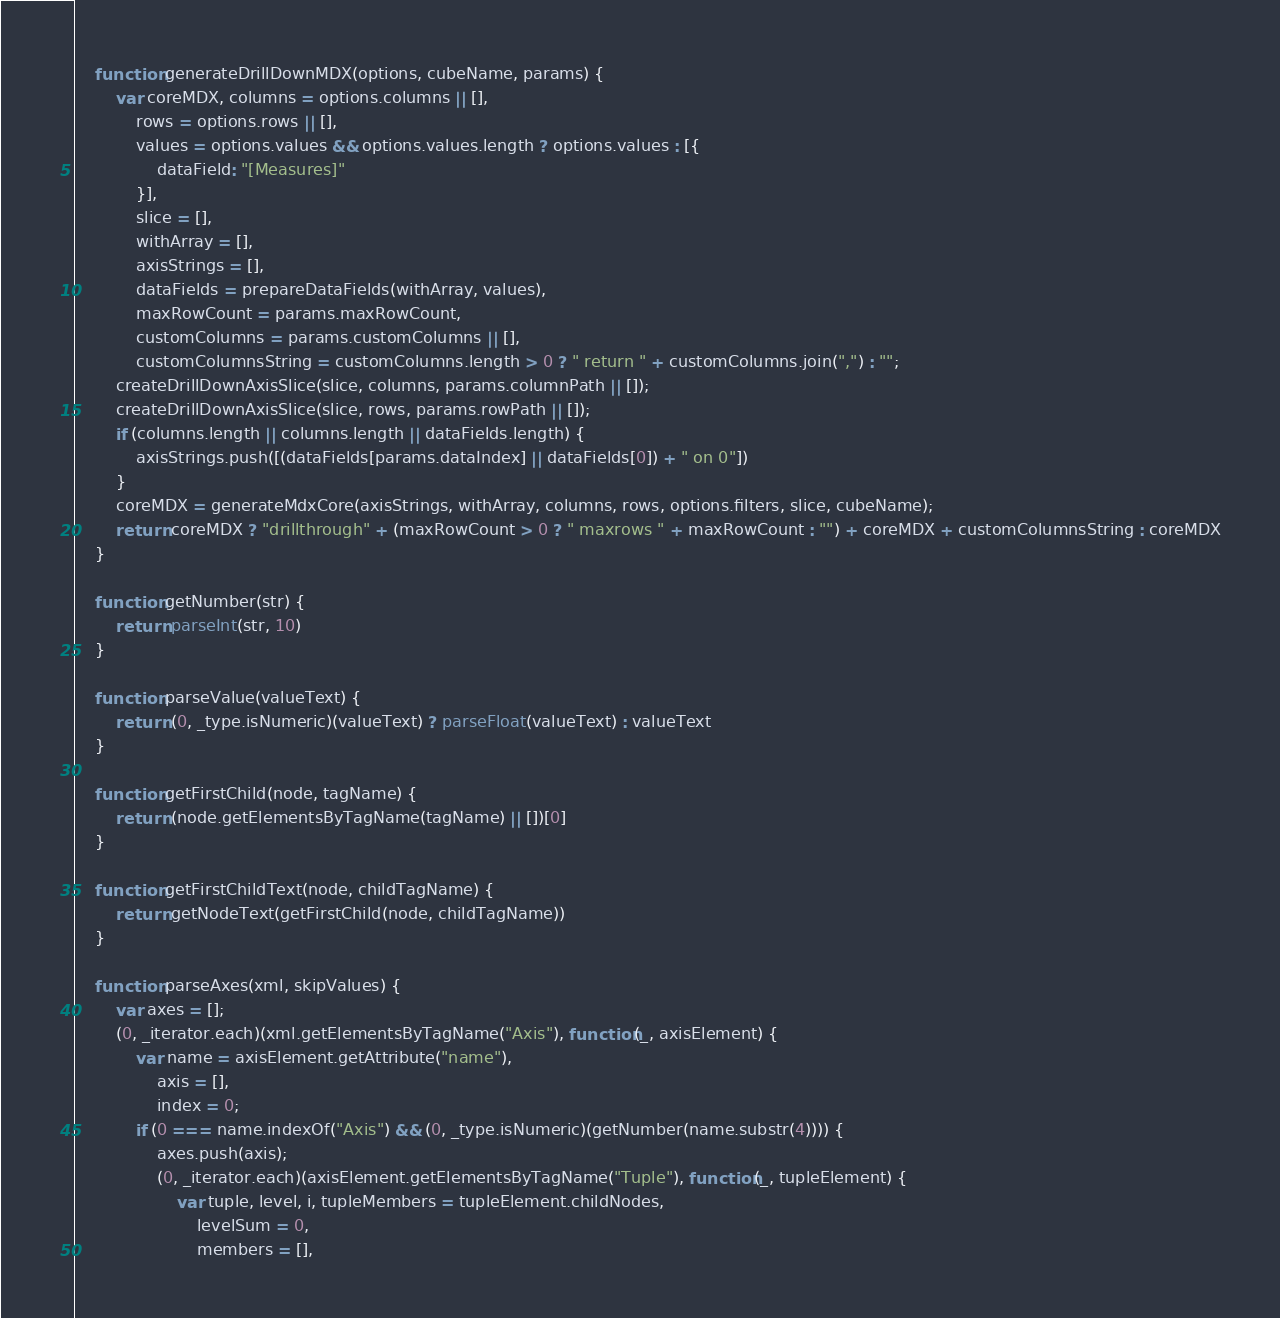<code> <loc_0><loc_0><loc_500><loc_500><_JavaScript_>
    function generateDrillDownMDX(options, cubeName, params) {
        var coreMDX, columns = options.columns || [],
            rows = options.rows || [],
            values = options.values && options.values.length ? options.values : [{
                dataField: "[Measures]"
            }],
            slice = [],
            withArray = [],
            axisStrings = [],
            dataFields = prepareDataFields(withArray, values),
            maxRowCount = params.maxRowCount,
            customColumns = params.customColumns || [],
            customColumnsString = customColumns.length > 0 ? " return " + customColumns.join(",") : "";
        createDrillDownAxisSlice(slice, columns, params.columnPath || []);
        createDrillDownAxisSlice(slice, rows, params.rowPath || []);
        if (columns.length || columns.length || dataFields.length) {
            axisStrings.push([(dataFields[params.dataIndex] || dataFields[0]) + " on 0"])
        }
        coreMDX = generateMdxCore(axisStrings, withArray, columns, rows, options.filters, slice, cubeName);
        return coreMDX ? "drillthrough" + (maxRowCount > 0 ? " maxrows " + maxRowCount : "") + coreMDX + customColumnsString : coreMDX
    }

    function getNumber(str) {
        return parseInt(str, 10)
    }

    function parseValue(valueText) {
        return (0, _type.isNumeric)(valueText) ? parseFloat(valueText) : valueText
    }

    function getFirstChild(node, tagName) {
        return (node.getElementsByTagName(tagName) || [])[0]
    }

    function getFirstChildText(node, childTagName) {
        return getNodeText(getFirstChild(node, childTagName))
    }

    function parseAxes(xml, skipValues) {
        var axes = [];
        (0, _iterator.each)(xml.getElementsByTagName("Axis"), function(_, axisElement) {
            var name = axisElement.getAttribute("name"),
                axis = [],
                index = 0;
            if (0 === name.indexOf("Axis") && (0, _type.isNumeric)(getNumber(name.substr(4)))) {
                axes.push(axis);
                (0, _iterator.each)(axisElement.getElementsByTagName("Tuple"), function(_, tupleElement) {
                    var tuple, level, i, tupleMembers = tupleElement.childNodes,
                        levelSum = 0,
                        members = [],</code> 